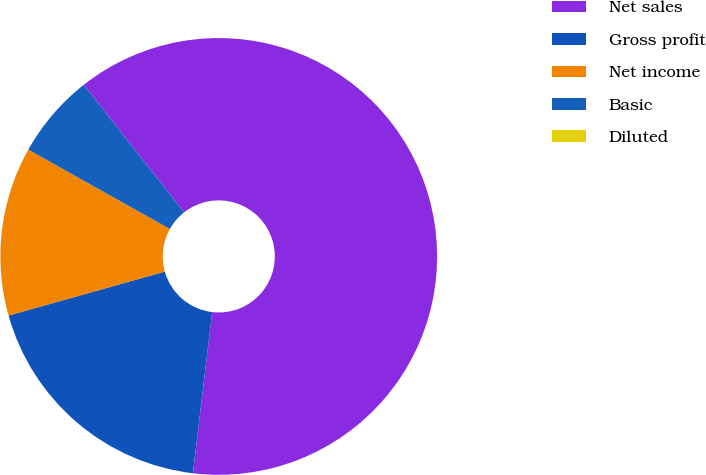Convert chart. <chart><loc_0><loc_0><loc_500><loc_500><pie_chart><fcel>Net sales<fcel>Gross profit<fcel>Net income<fcel>Basic<fcel>Diluted<nl><fcel>62.5%<fcel>18.75%<fcel>12.5%<fcel>6.25%<fcel>0.0%<nl></chart> 